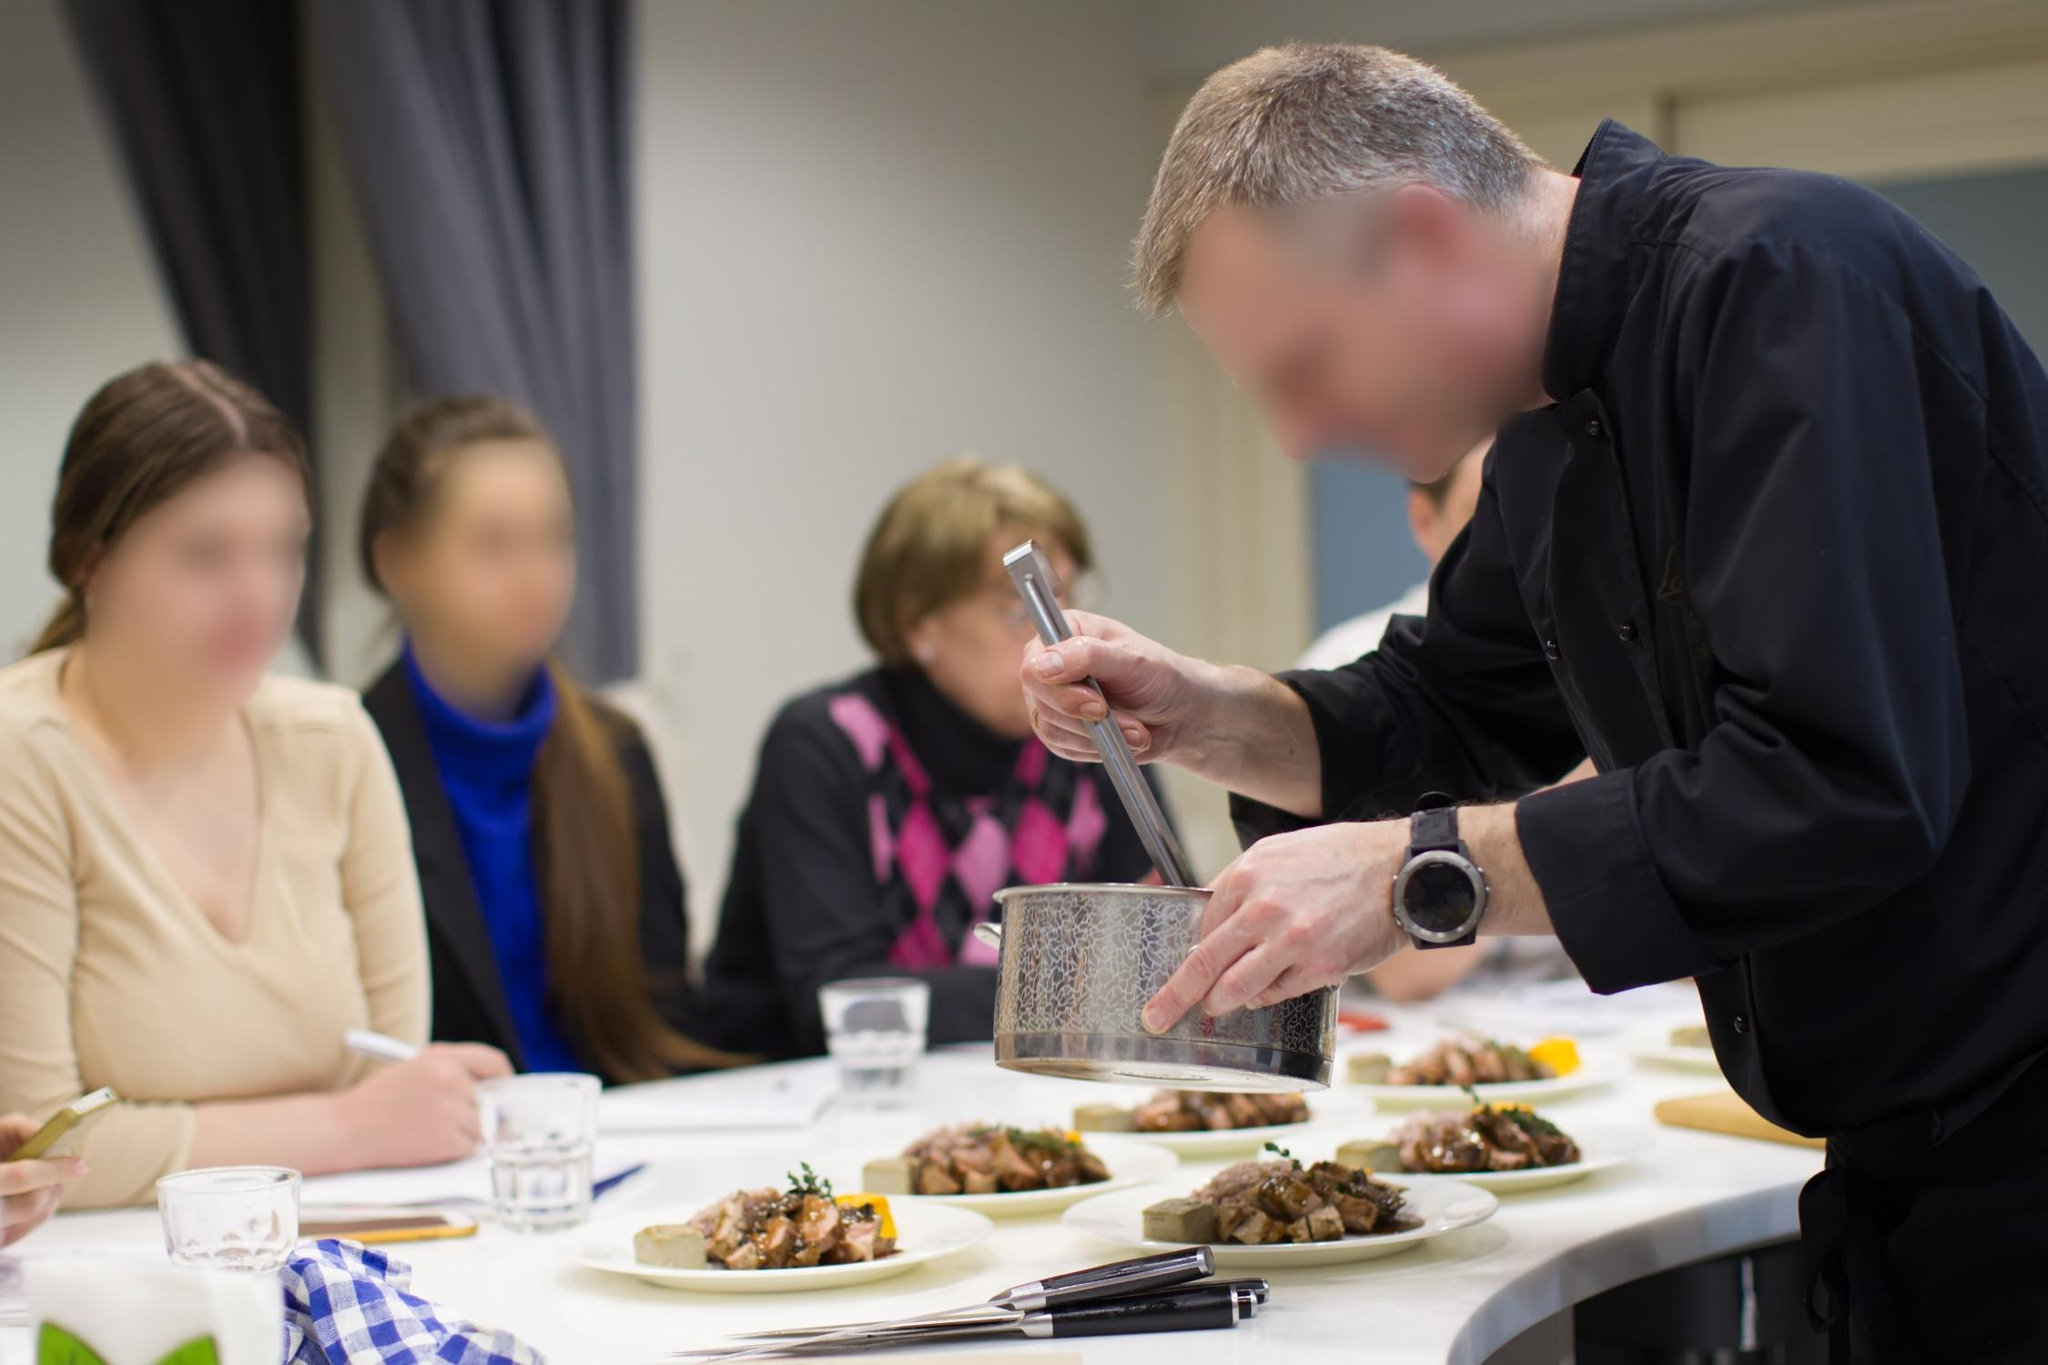Imagine if one of the spectators decided to join the chef. How might this interaction unfold? If one of the spectators decided to join the chef, the interaction would likely begin with the chef welcoming them to the counter and handing them a clean apron. He might then guide the spectator through the process of preparing the dish, offering tips and encouraging questions. The spectator would try their hand at grating cheese, perhaps a bit awkwardly at first, but with the chef's patient instruction, they would improve. This hands-on experience would be both enlightening and fun, with the spectator gaining newfound appreciation for the skill and precision involved in professional cooking. 